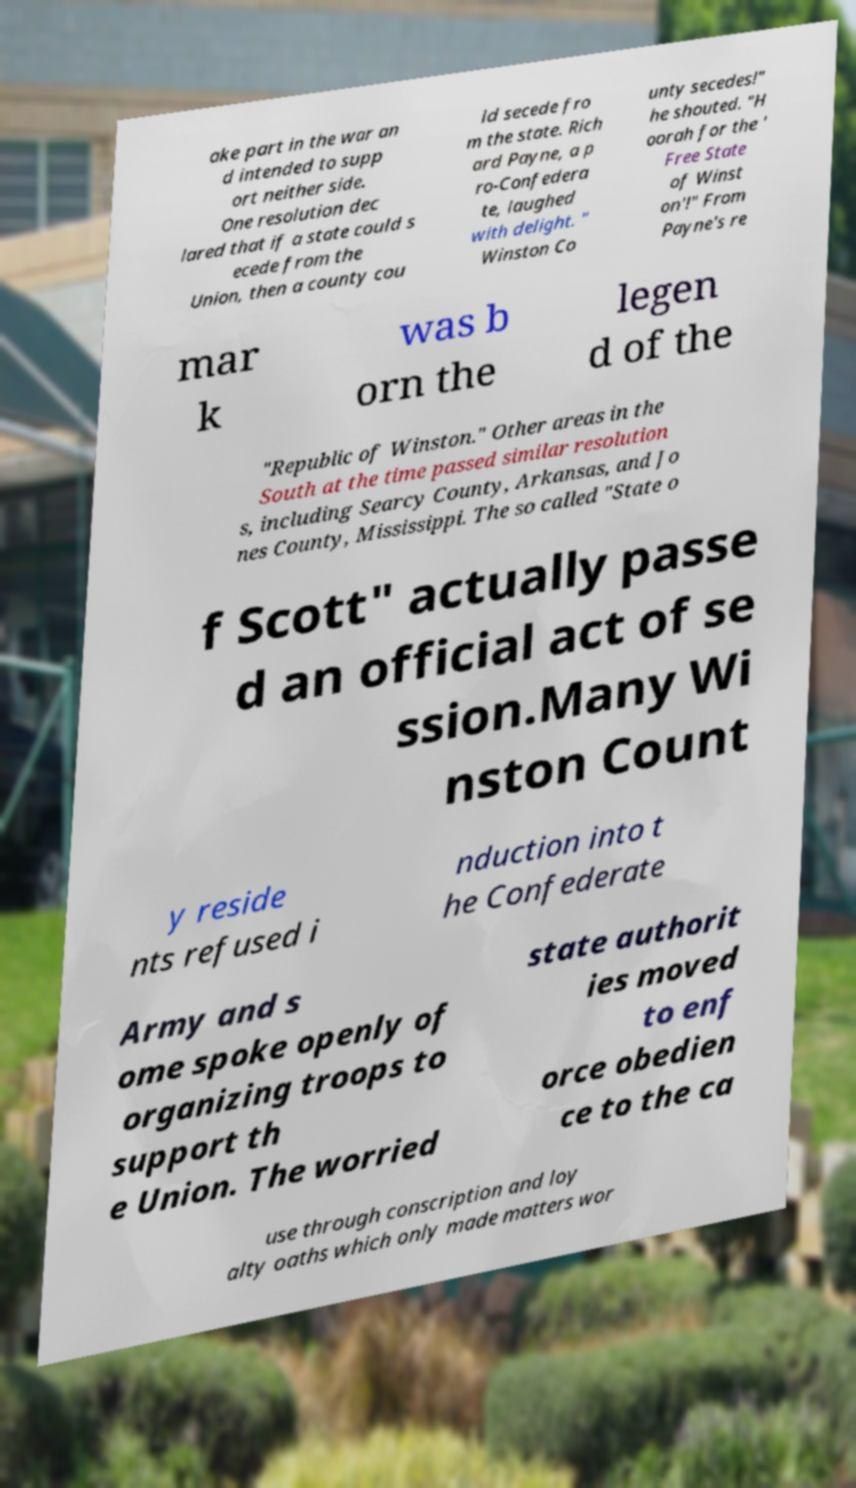There's text embedded in this image that I need extracted. Can you transcribe it verbatim? ake part in the war an d intended to supp ort neither side. One resolution dec lared that if a state could s ecede from the Union, then a county cou ld secede fro m the state. Rich ard Payne, a p ro-Confedera te, laughed with delight. " Winston Co unty secedes!" he shouted. "H oorah for the ' Free State of Winst on'!" From Payne's re mar k was b orn the legen d of the "Republic of Winston." Other areas in the South at the time passed similar resolution s, including Searcy County, Arkansas, and Jo nes County, Mississippi. The so called "State o f Scott" actually passe d an official act of se ssion.Many Wi nston Count y reside nts refused i nduction into t he Confederate Army and s ome spoke openly of organizing troops to support th e Union. The worried state authorit ies moved to enf orce obedien ce to the ca use through conscription and loy alty oaths which only made matters wor 